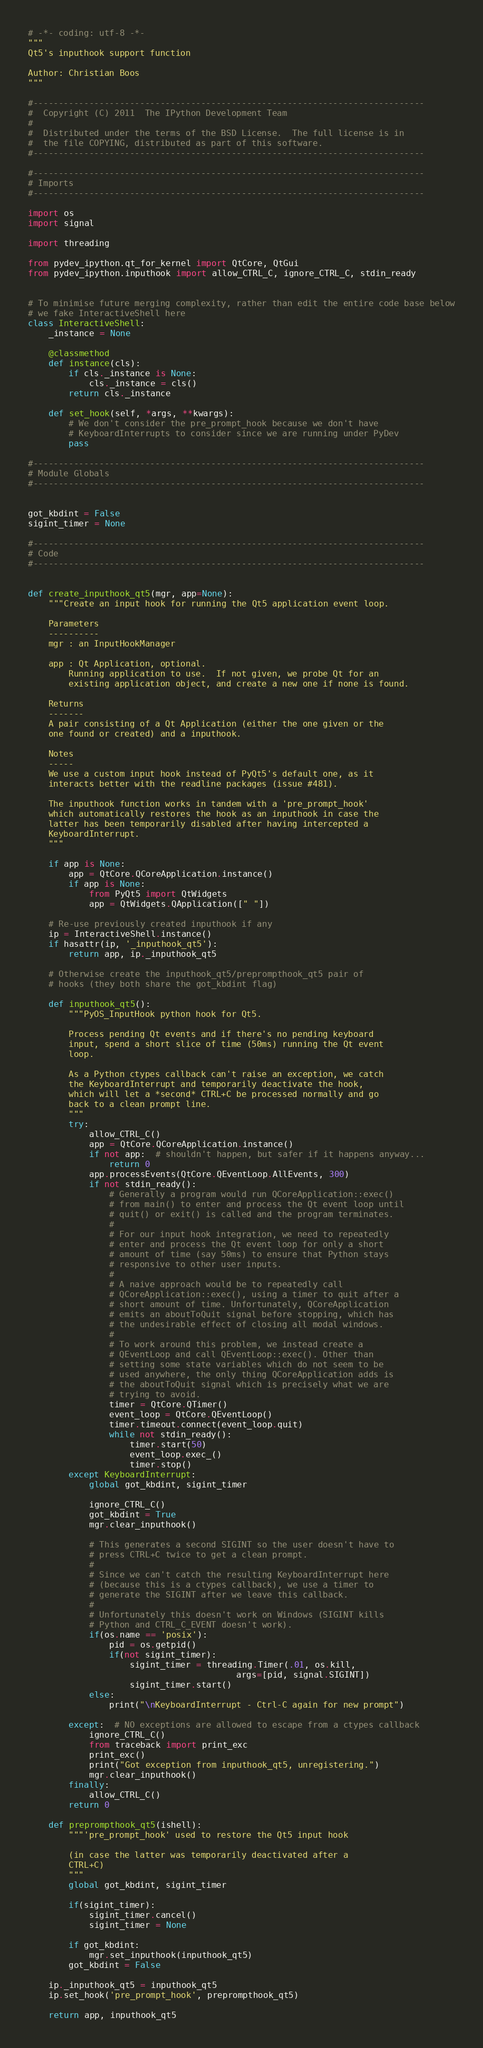<code> <loc_0><loc_0><loc_500><loc_500><_Python_># -*- coding: utf-8 -*-
"""
Qt5's inputhook support function

Author: Christian Boos
"""

#-----------------------------------------------------------------------------
#  Copyright (C) 2011  The IPython Development Team
#
#  Distributed under the terms of the BSD License.  The full license is in
#  the file COPYING, distributed as part of this software.
#-----------------------------------------------------------------------------

#-----------------------------------------------------------------------------
# Imports
#-----------------------------------------------------------------------------

import os
import signal

import threading

from pydev_ipython.qt_for_kernel import QtCore, QtGui
from pydev_ipython.inputhook import allow_CTRL_C, ignore_CTRL_C, stdin_ready


# To minimise future merging complexity, rather than edit the entire code base below
# we fake InteractiveShell here
class InteractiveShell:
    _instance = None

    @classmethod
    def instance(cls):
        if cls._instance is None:
            cls._instance = cls()
        return cls._instance

    def set_hook(self, *args, **kwargs):
        # We don't consider the pre_prompt_hook because we don't have
        # KeyboardInterrupts to consider since we are running under PyDev
        pass

#-----------------------------------------------------------------------------
# Module Globals
#-----------------------------------------------------------------------------


got_kbdint = False
sigint_timer = None

#-----------------------------------------------------------------------------
# Code
#-----------------------------------------------------------------------------


def create_inputhook_qt5(mgr, app=None):
    """Create an input hook for running the Qt5 application event loop.

    Parameters
    ----------
    mgr : an InputHookManager

    app : Qt Application, optional.
        Running application to use.  If not given, we probe Qt for an
        existing application object, and create a new one if none is found.

    Returns
    -------
    A pair consisting of a Qt Application (either the one given or the
    one found or created) and a inputhook.

    Notes
    -----
    We use a custom input hook instead of PyQt5's default one, as it
    interacts better with the readline packages (issue #481).

    The inputhook function works in tandem with a 'pre_prompt_hook'
    which automatically restores the hook as an inputhook in case the
    latter has been temporarily disabled after having intercepted a
    KeyboardInterrupt.
    """

    if app is None:
        app = QtCore.QCoreApplication.instance()
        if app is None:
            from PyQt5 import QtWidgets
            app = QtWidgets.QApplication([" "])

    # Re-use previously created inputhook if any
    ip = InteractiveShell.instance()
    if hasattr(ip, '_inputhook_qt5'):
        return app, ip._inputhook_qt5

    # Otherwise create the inputhook_qt5/preprompthook_qt5 pair of
    # hooks (they both share the got_kbdint flag)

    def inputhook_qt5():
        """PyOS_InputHook python hook for Qt5.

        Process pending Qt events and if there's no pending keyboard
        input, spend a short slice of time (50ms) running the Qt event
        loop.

        As a Python ctypes callback can't raise an exception, we catch
        the KeyboardInterrupt and temporarily deactivate the hook,
        which will let a *second* CTRL+C be processed normally and go
        back to a clean prompt line.
        """
        try:
            allow_CTRL_C()
            app = QtCore.QCoreApplication.instance()
            if not app:  # shouldn't happen, but safer if it happens anyway...
                return 0
            app.processEvents(QtCore.QEventLoop.AllEvents, 300)
            if not stdin_ready():
                # Generally a program would run QCoreApplication::exec()
                # from main() to enter and process the Qt event loop until
                # quit() or exit() is called and the program terminates.
                #
                # For our input hook integration, we need to repeatedly
                # enter and process the Qt event loop for only a short
                # amount of time (say 50ms) to ensure that Python stays
                # responsive to other user inputs.
                #
                # A naive approach would be to repeatedly call
                # QCoreApplication::exec(), using a timer to quit after a
                # short amount of time. Unfortunately, QCoreApplication
                # emits an aboutToQuit signal before stopping, which has
                # the undesirable effect of closing all modal windows.
                #
                # To work around this problem, we instead create a
                # QEventLoop and call QEventLoop::exec(). Other than
                # setting some state variables which do not seem to be
                # used anywhere, the only thing QCoreApplication adds is
                # the aboutToQuit signal which is precisely what we are
                # trying to avoid.
                timer = QtCore.QTimer()
                event_loop = QtCore.QEventLoop()
                timer.timeout.connect(event_loop.quit)
                while not stdin_ready():
                    timer.start(50)
                    event_loop.exec_()
                    timer.stop()
        except KeyboardInterrupt:
            global got_kbdint, sigint_timer

            ignore_CTRL_C()
            got_kbdint = True
            mgr.clear_inputhook()

            # This generates a second SIGINT so the user doesn't have to
            # press CTRL+C twice to get a clean prompt.
            #
            # Since we can't catch the resulting KeyboardInterrupt here
            # (because this is a ctypes callback), we use a timer to
            # generate the SIGINT after we leave this callback.
            #
            # Unfortunately this doesn't work on Windows (SIGINT kills
            # Python and CTRL_C_EVENT doesn't work).
            if(os.name == 'posix'):
                pid = os.getpid()
                if(not sigint_timer):
                    sigint_timer = threading.Timer(.01, os.kill,
                                         args=[pid, signal.SIGINT])
                    sigint_timer.start()
            else:
                print("\nKeyboardInterrupt - Ctrl-C again for new prompt")

        except:  # NO exceptions are allowed to escape from a ctypes callback
            ignore_CTRL_C()
            from traceback import print_exc
            print_exc()
            print("Got exception from inputhook_qt5, unregistering.")
            mgr.clear_inputhook()
        finally:
            allow_CTRL_C()
        return 0

    def preprompthook_qt5(ishell):
        """'pre_prompt_hook' used to restore the Qt5 input hook

        (in case the latter was temporarily deactivated after a
        CTRL+C)
        """
        global got_kbdint, sigint_timer

        if(sigint_timer):
            sigint_timer.cancel()
            sigint_timer = None

        if got_kbdint:
            mgr.set_inputhook(inputhook_qt5)
        got_kbdint = False

    ip._inputhook_qt5 = inputhook_qt5
    ip.set_hook('pre_prompt_hook', preprompthook_qt5)

    return app, inputhook_qt5
</code> 